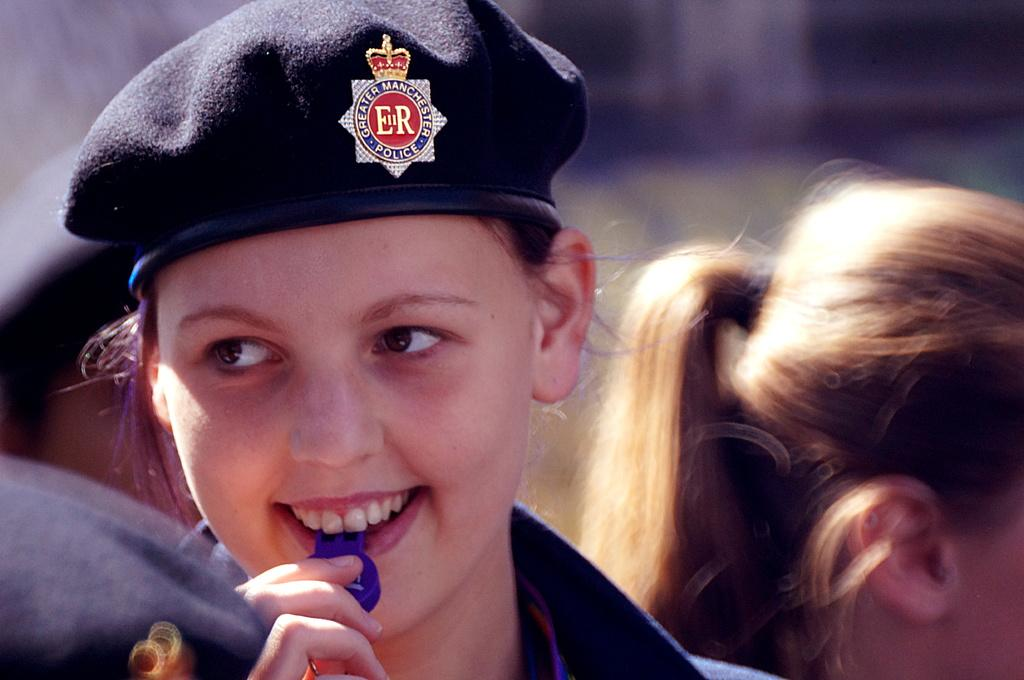Who is present in the image? There is a woman in the image. What is the woman doing in the image? The woman is smiling in the image. What is the woman wearing on her head? The woman is wearing a cap in the image. Can you describe the background of the image? There are persons visible in the background of the image. What type of wax is being applied to the woman's face in the image? There is no wax or any indication of a beauty treatment being performed in the image. 